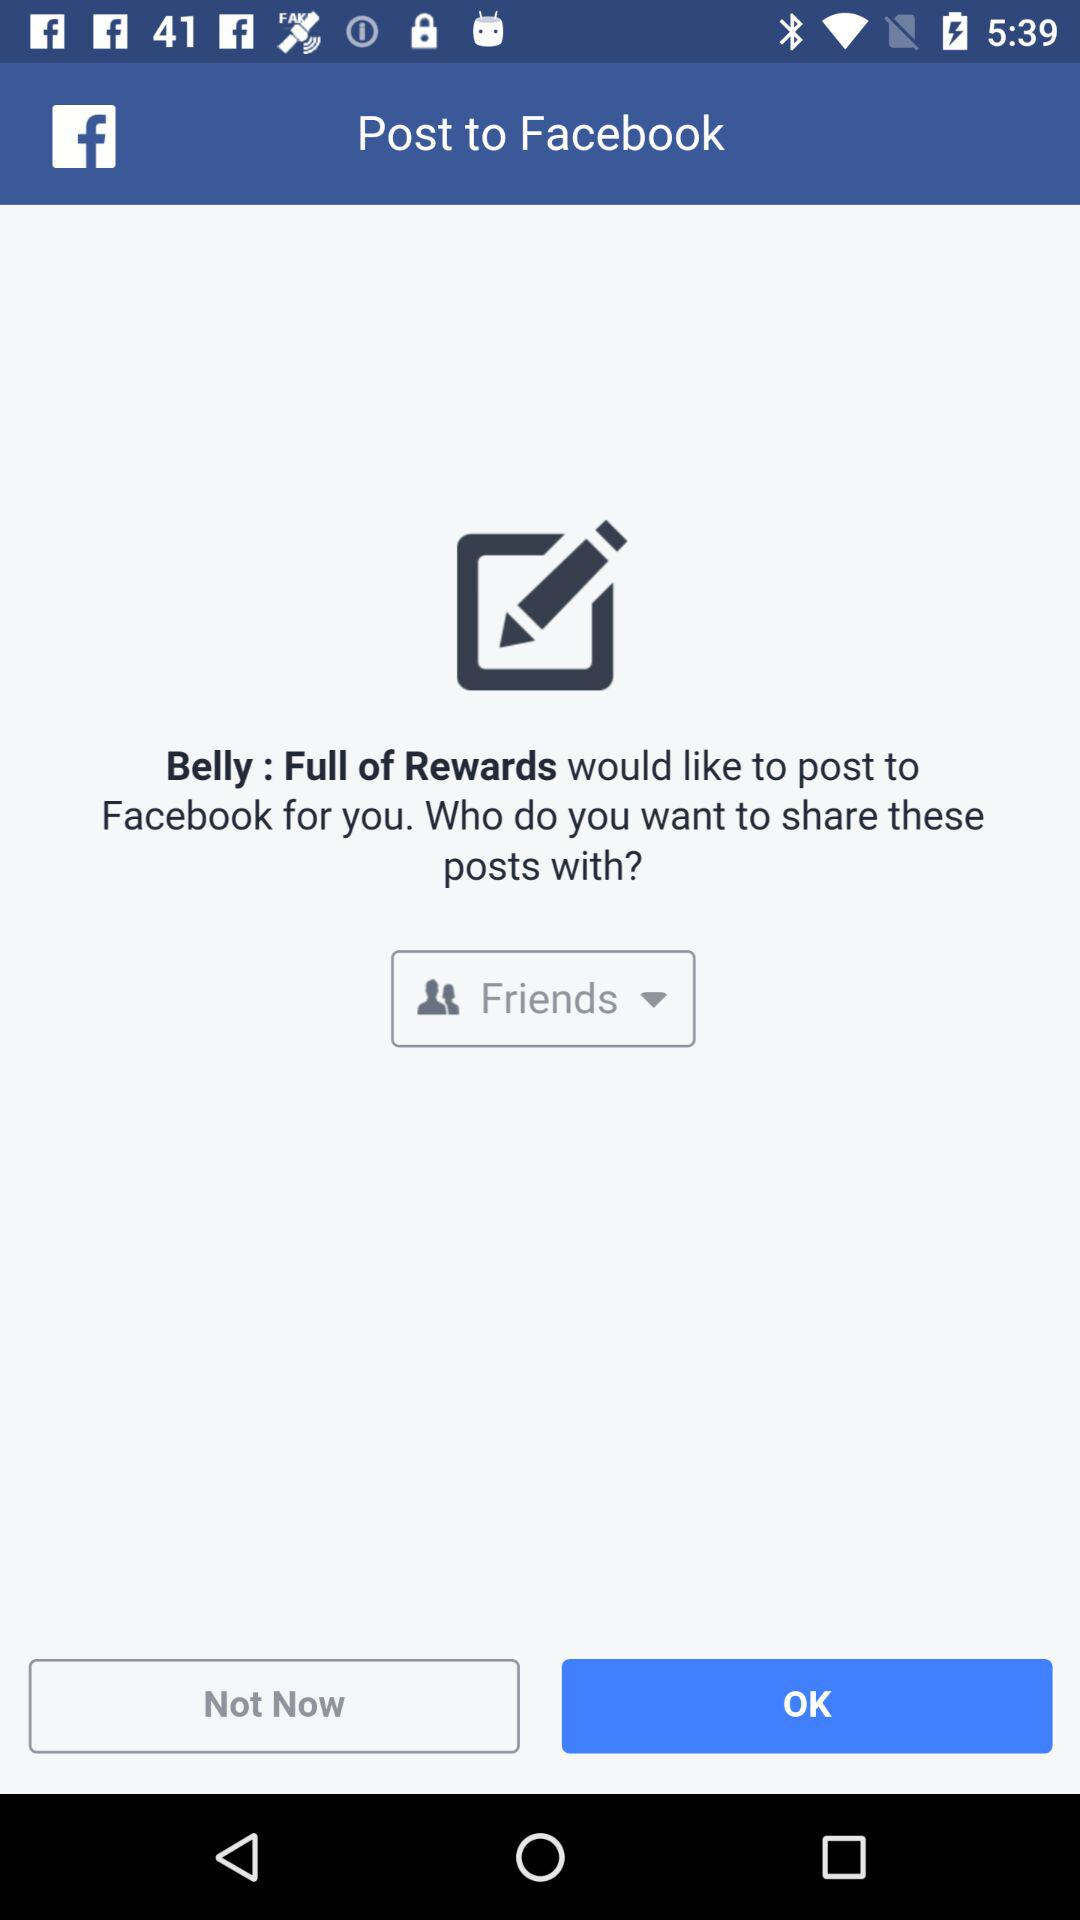What application can we use to post? We can use "Facebook". 